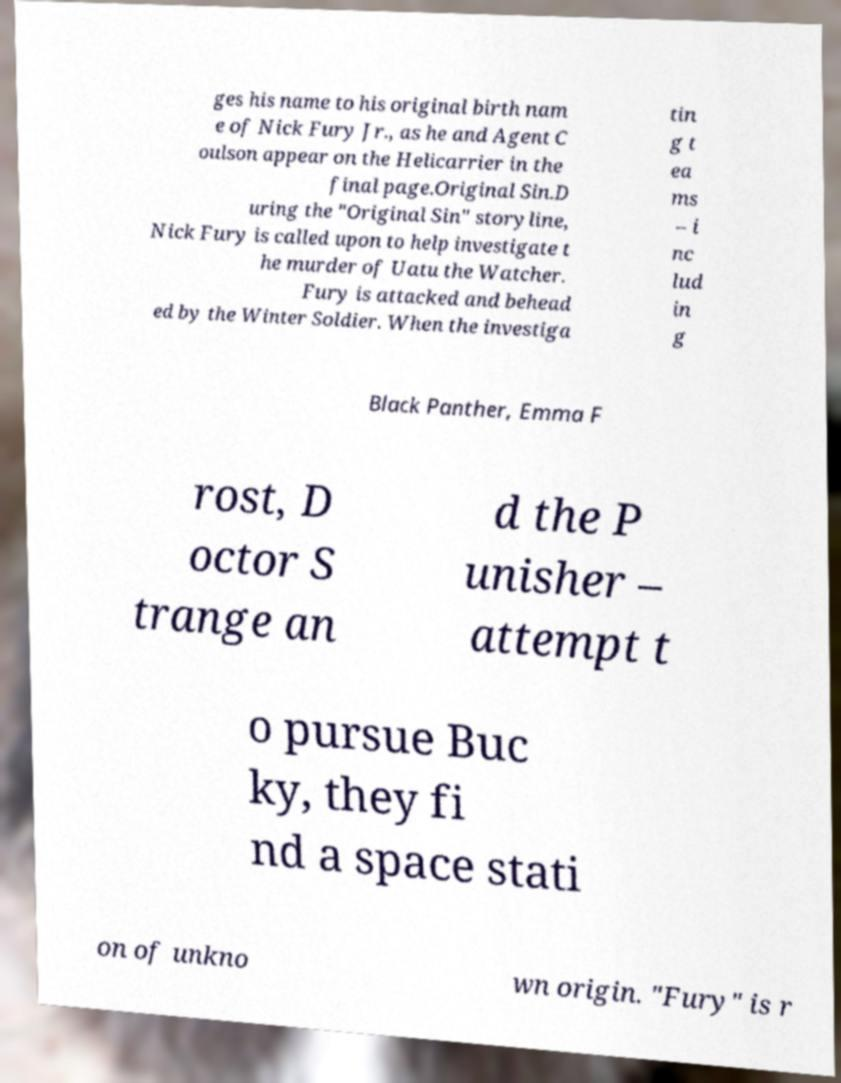I need the written content from this picture converted into text. Can you do that? ges his name to his original birth nam e of Nick Fury Jr., as he and Agent C oulson appear on the Helicarrier in the final page.Original Sin.D uring the "Original Sin" storyline, Nick Fury is called upon to help investigate t he murder of Uatu the Watcher. Fury is attacked and behead ed by the Winter Soldier. When the investiga tin g t ea ms – i nc lud in g Black Panther, Emma F rost, D octor S trange an d the P unisher – attempt t o pursue Buc ky, they fi nd a space stati on of unkno wn origin. "Fury" is r 